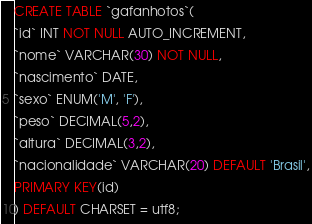<code> <loc_0><loc_0><loc_500><loc_500><_SQL_>
CREATE TABLE `gafanhotos`(
`id` INT NOT NULL AUTO_INCREMENT,
`nome` VARCHAR(30) NOT NULL,
`nascimento` DATE,
`sexo` ENUM('M', 'F'),
`peso` DECIMAL(5,2),
`altura` DECIMAL(3,2),
`nacionalidade` VARCHAR(20) DEFAULT 'Brasil',
PRIMARY KEY(id)
) DEFAULT CHARSET = utf8; </code> 